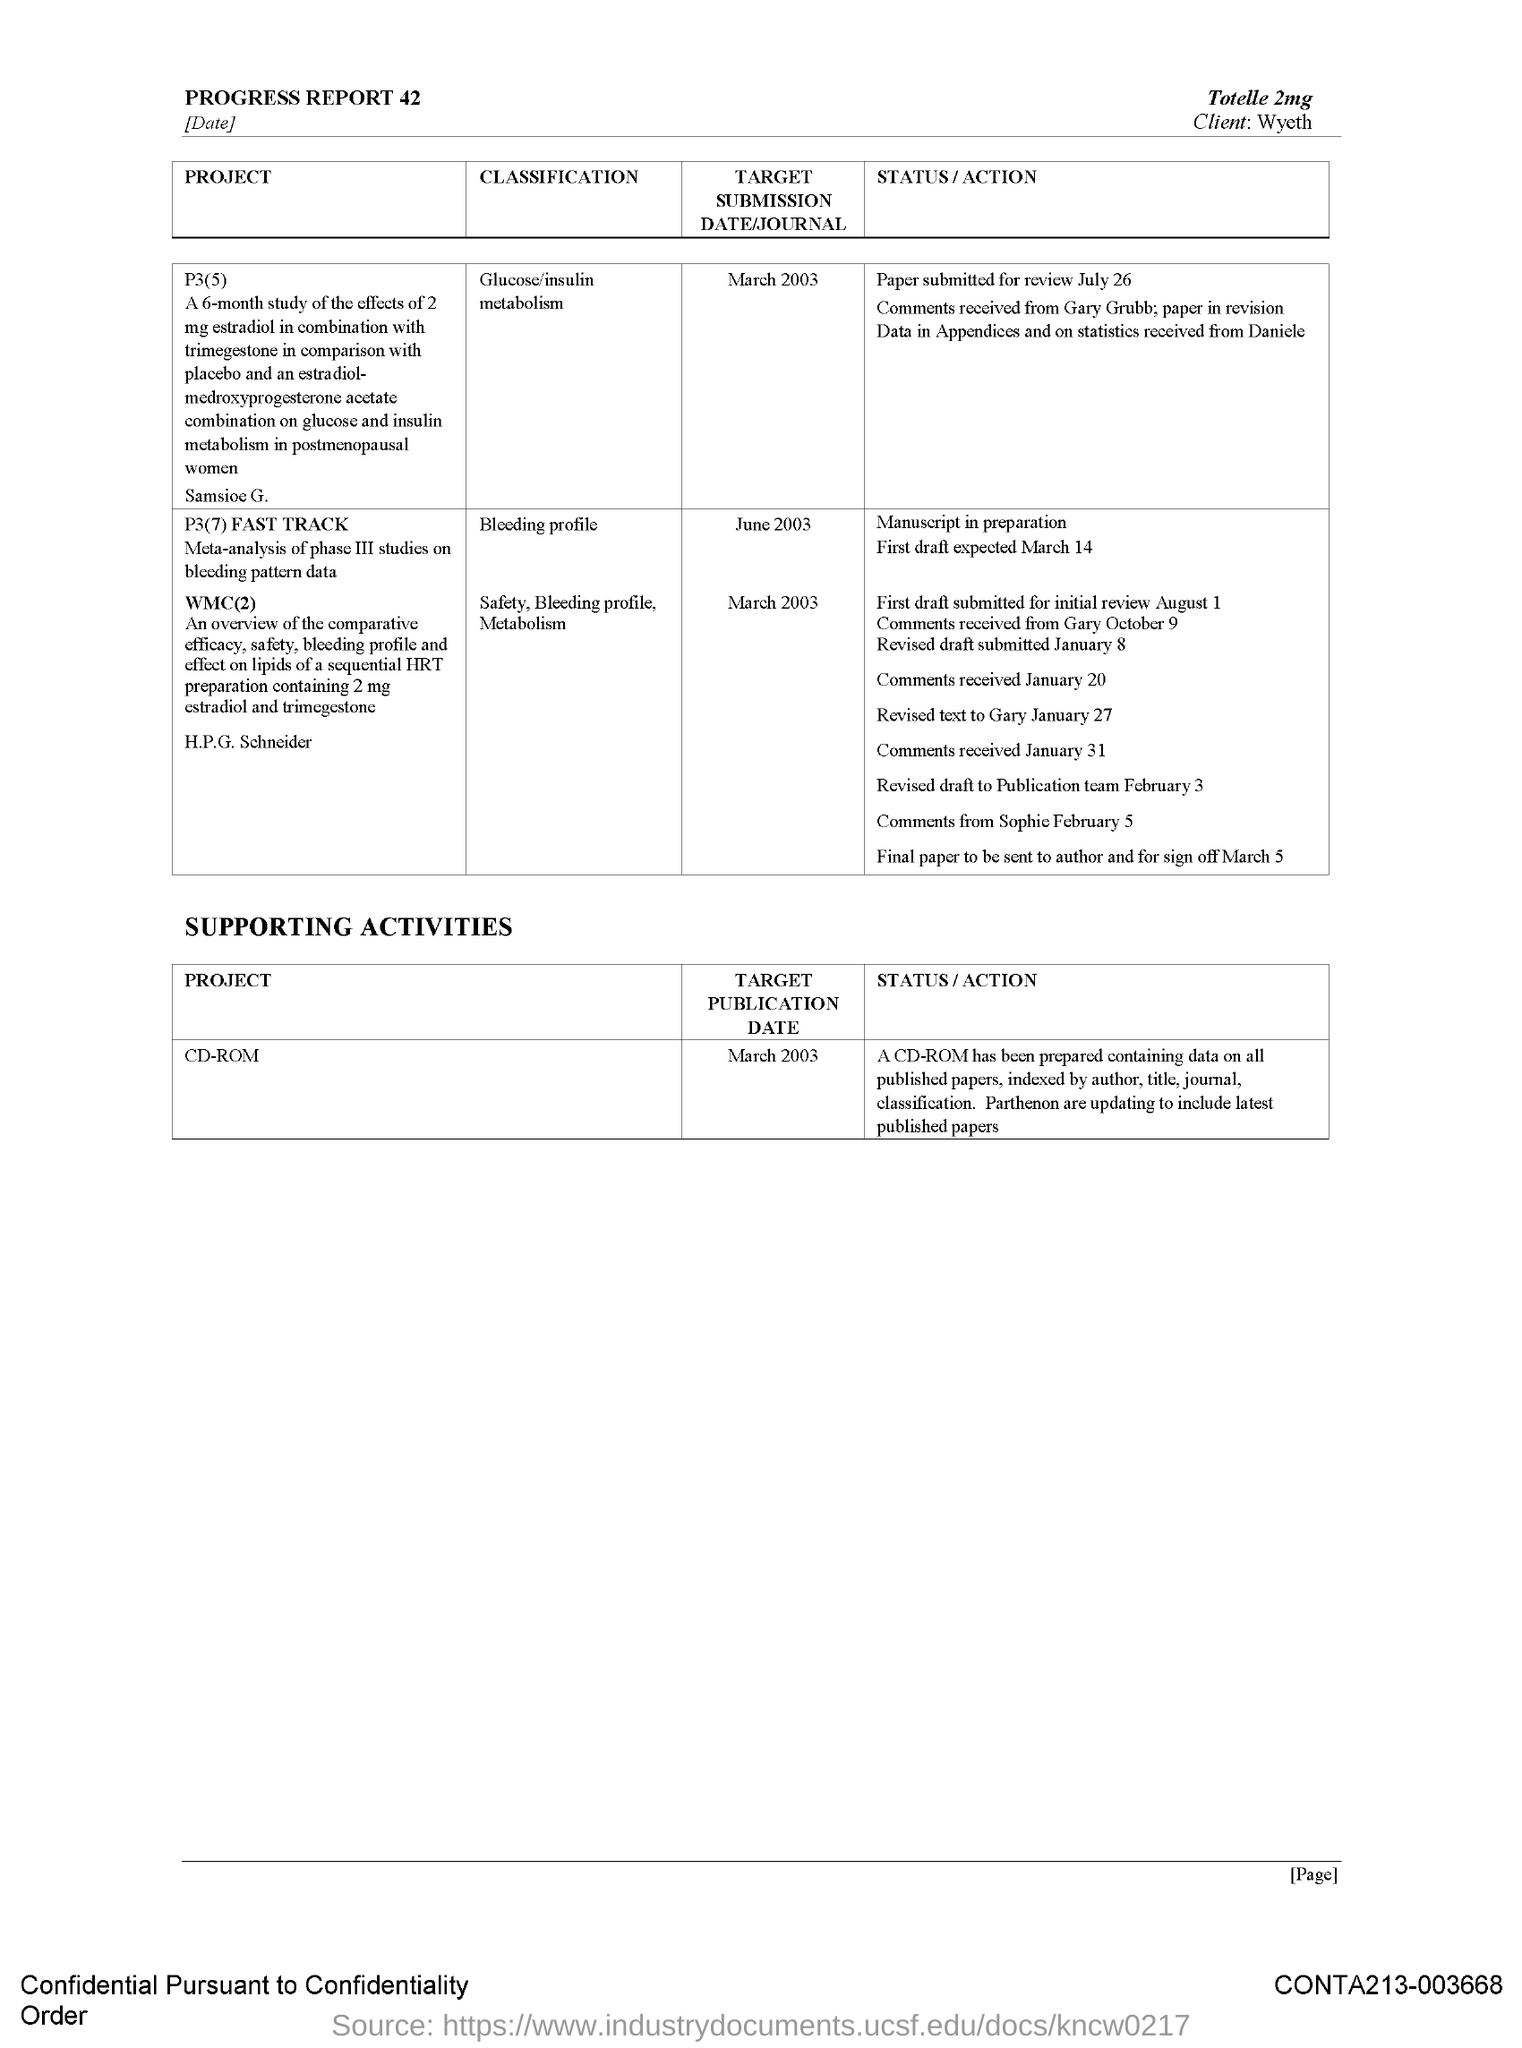Draw attention to some important aspects in this diagram. The project P3(5) is classified as being related to glucose/insulin metabolism. The status of P3(7) is that it is expected to be completed by March 14th, and a first draft of this task is expected to be submitted on that date. The target publication date of the CD-ROM is March 2003. The client is Wyeth. The target submission date for WMC(2) is March 2003. 